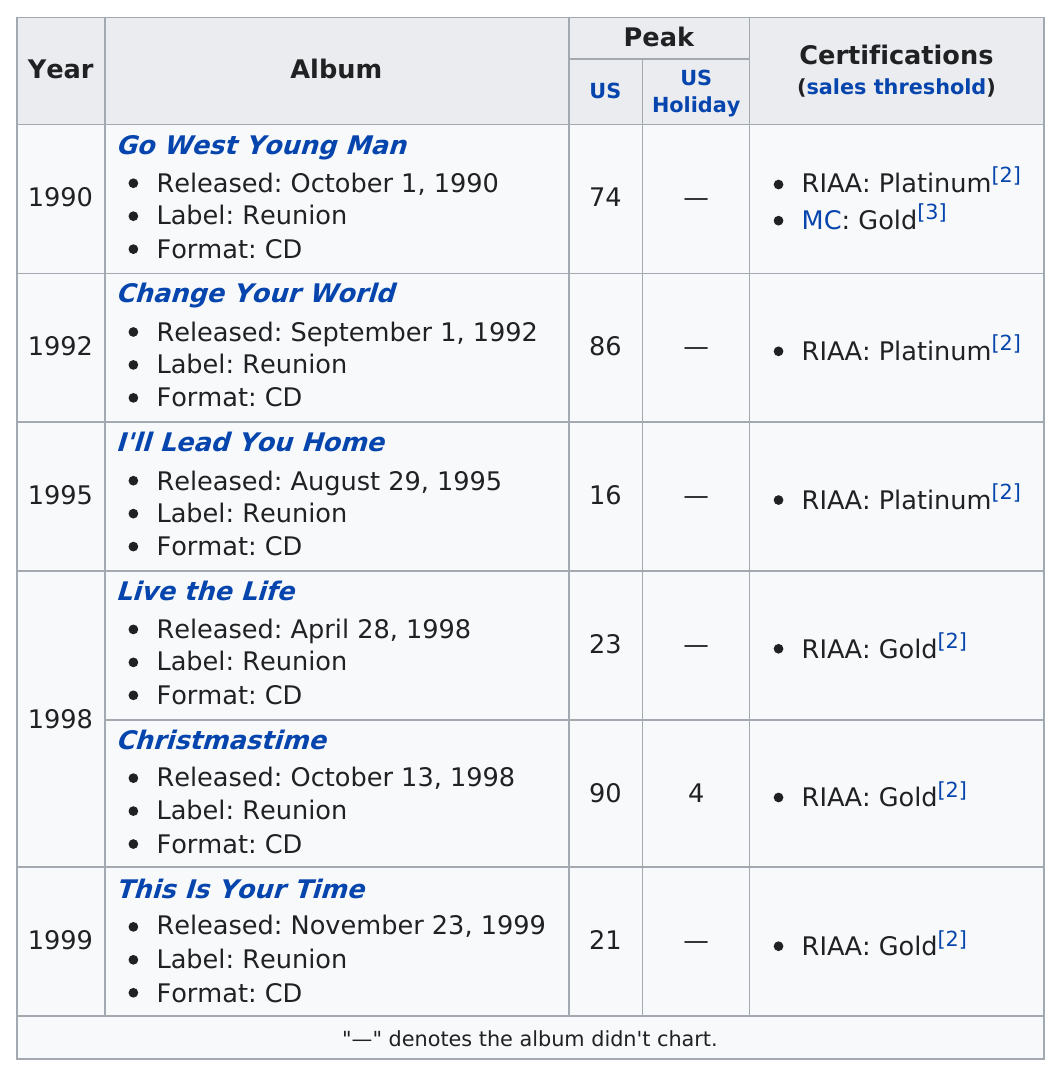Highlight a few significant elements in this photo. There are two songs listed from 1998. Go West Young Man" has the greater number of certifications compared to "Live the Life. The year after 1995 is 1998. The oldest year listed is 1990. The RIAA certification for "Gold" is one of several certifications, with the other being "Platinum. 